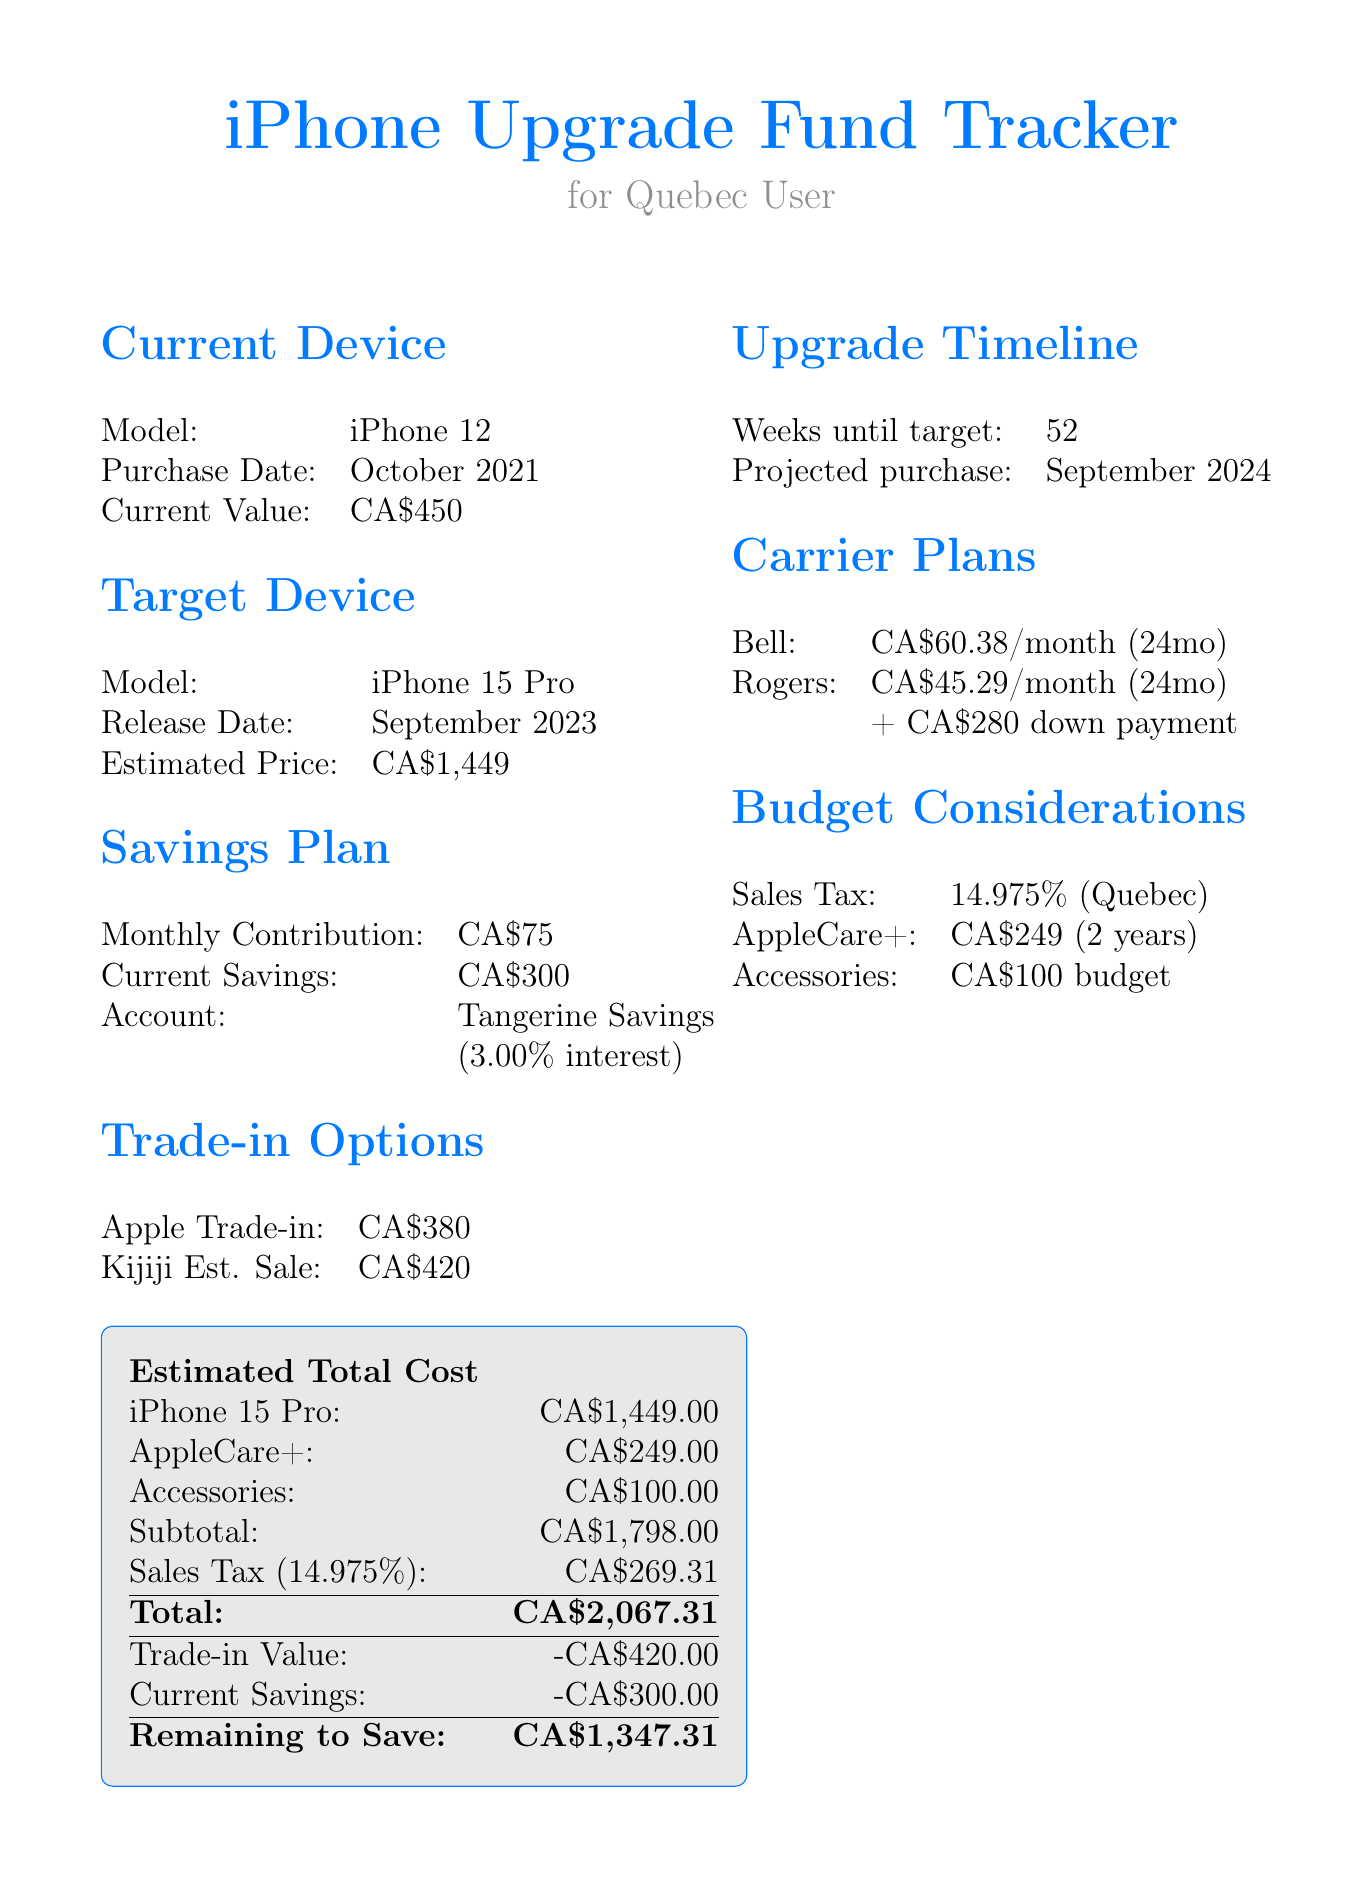What model is the current device? The current device model is stated in the document under the "Current Device" section.
Answer: iPhone 12 When was the current device purchased? The purchase date of the current device is mentioned in the same section.
Answer: October 2021 What is the estimated price of the target device? The estimated price is provided under the "Target Device" section.
Answer: CA$1,449 How much is the monthly contribution to savings? The monthly contribution figure is found in the "Savings Plan" section.
Answer: CA$75 What is the trade-in value offered by Apple? The trade-in value is specified under the "Trade-in Options" section.
Answer: CA$380 How many weeks until the target device can be purchased? The number of weeks until the target is detailed in the "Upgrade Timeline."
Answer: 52 What is the total estimated cost including sales tax? The total estimated cost is calculated in the "Estimated Total Cost" section.
Answer: CA$2,067.31 What is the remaining amount to save? The remaining amount to save is provided at the bottom of the "Estimated Total Cost" section.
Answer: CA$1,347.31 What is the carrier plan monthly cost from Rogers? The monthly cost for the Rogers carrier plan is detailed in the "Carrier Plans" section.
Answer: CA$45.29/month 